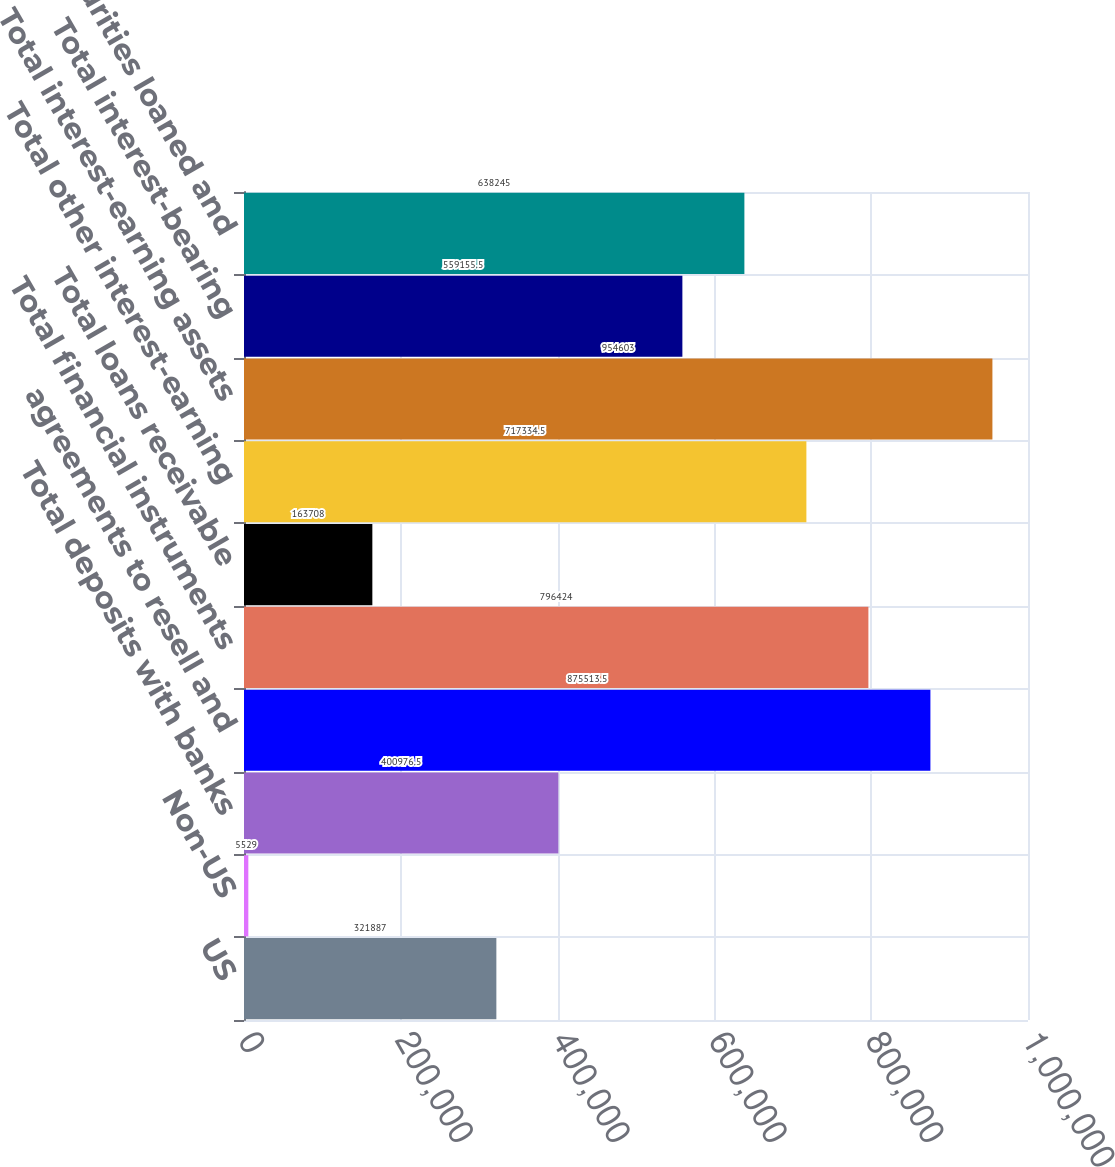<chart> <loc_0><loc_0><loc_500><loc_500><bar_chart><fcel>US<fcel>Non-US<fcel>Total deposits with banks<fcel>agreements to resell and<fcel>Total financial instruments<fcel>Total loans receivable<fcel>Total other interest-earning<fcel>Total interest-earning assets<fcel>Total interest-bearing<fcel>Total securities loaned and<nl><fcel>321887<fcel>5529<fcel>400976<fcel>875514<fcel>796424<fcel>163708<fcel>717334<fcel>954603<fcel>559156<fcel>638245<nl></chart> 